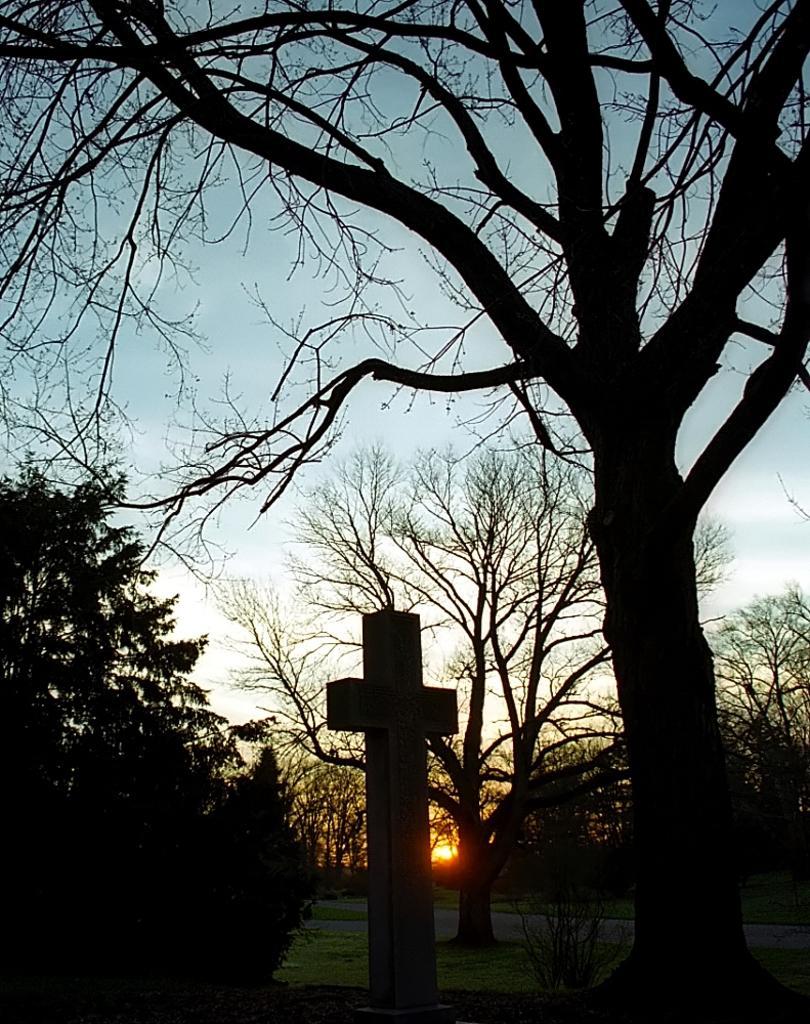Can you describe this image briefly? In the picture we can see a cross statue on the grass surface and beside it we can see a tree and on the other side we can see some plants and behind the plants we can see some dried trees and sky with sun. 